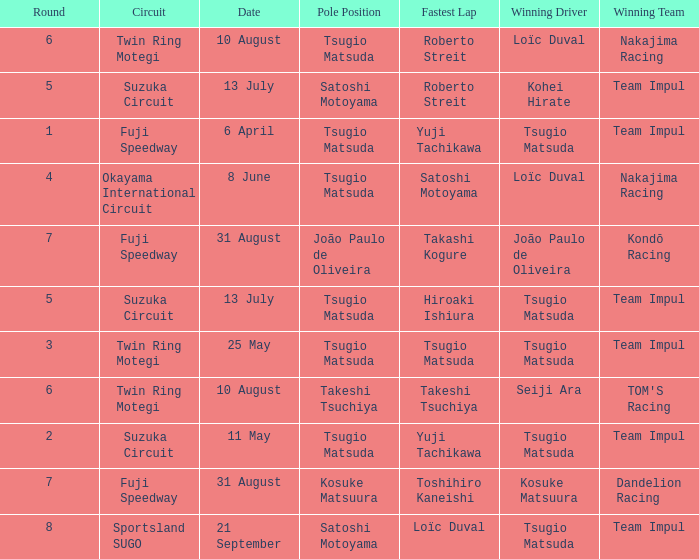On what date does Yuji Tachikawa have the fastest lap in round 1? 6 April. 